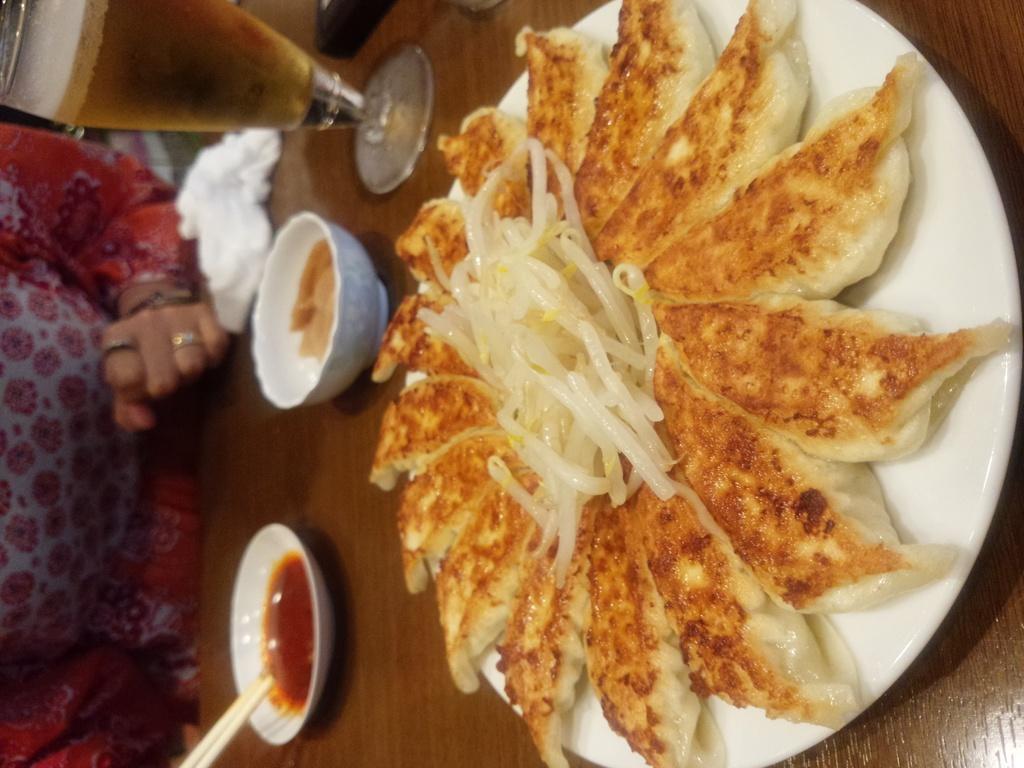Describe this image in one or two sentences. I can see a plate, bowls and a glass, which are placed on the wooden table. These bowls and a plate contains the food items. On the left side of the image, I can see a person. This looks like a tissue paper, which is on the table. 